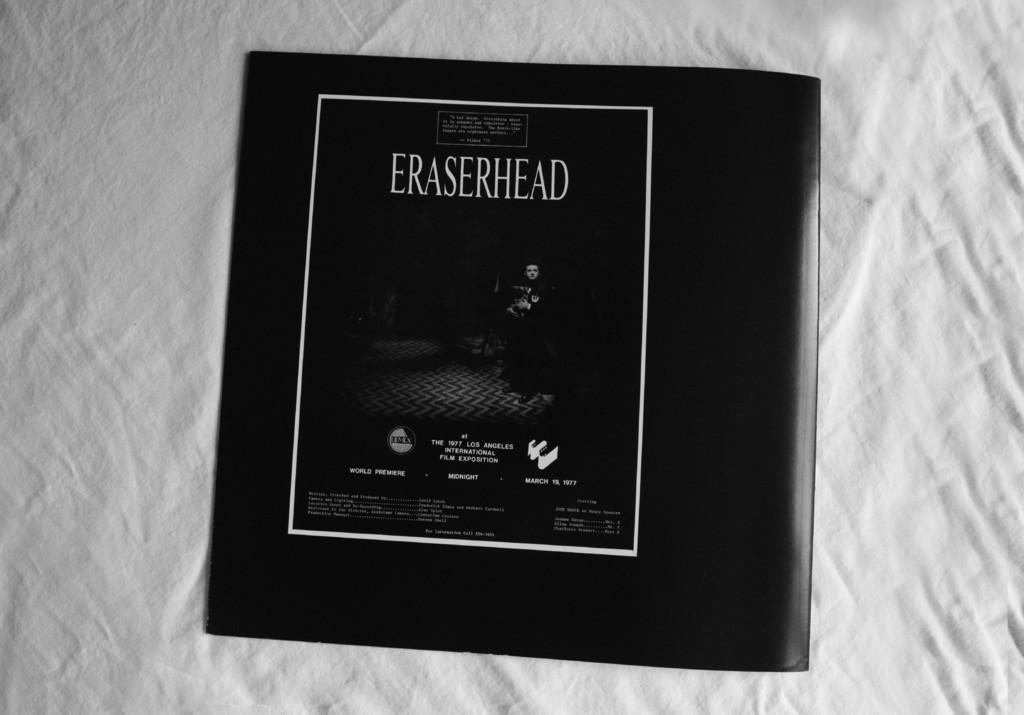What is the title of the movie?
Ensure brevity in your answer.  Eraserhead. What is laying on the bed?
Your response must be concise. Eraserhead. 